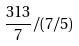<formula> <loc_0><loc_0><loc_500><loc_500>\frac { 3 1 3 } { 7 } / ( 7 / 5 )</formula> 